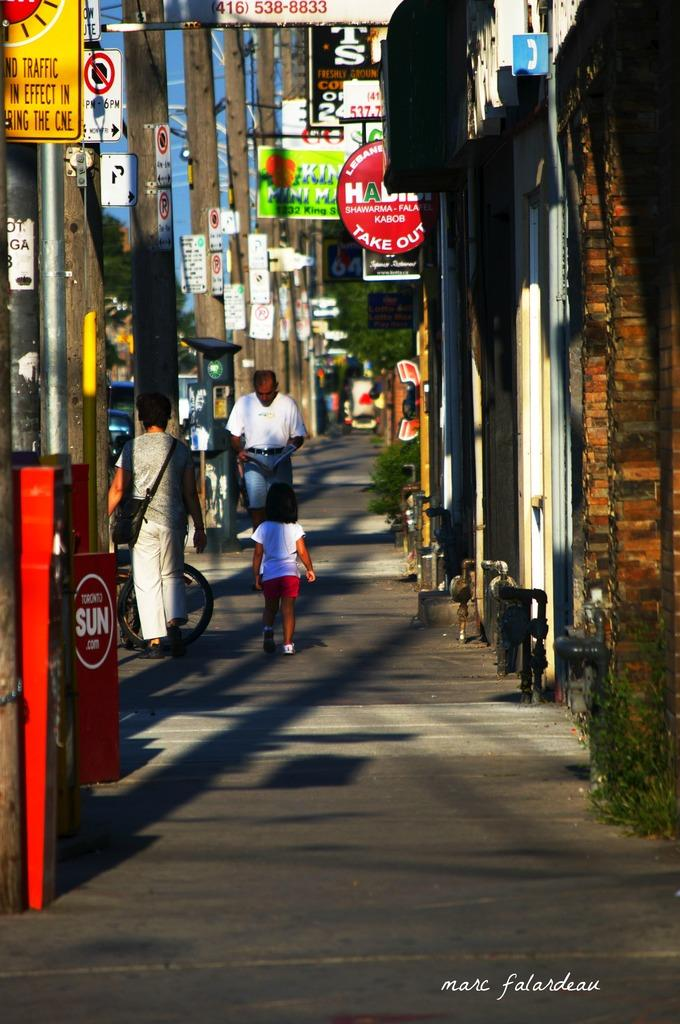<image>
Write a terse but informative summary of the picture. A street with alot of signs but the first yellow one on the left explains that traffic is in effect. 